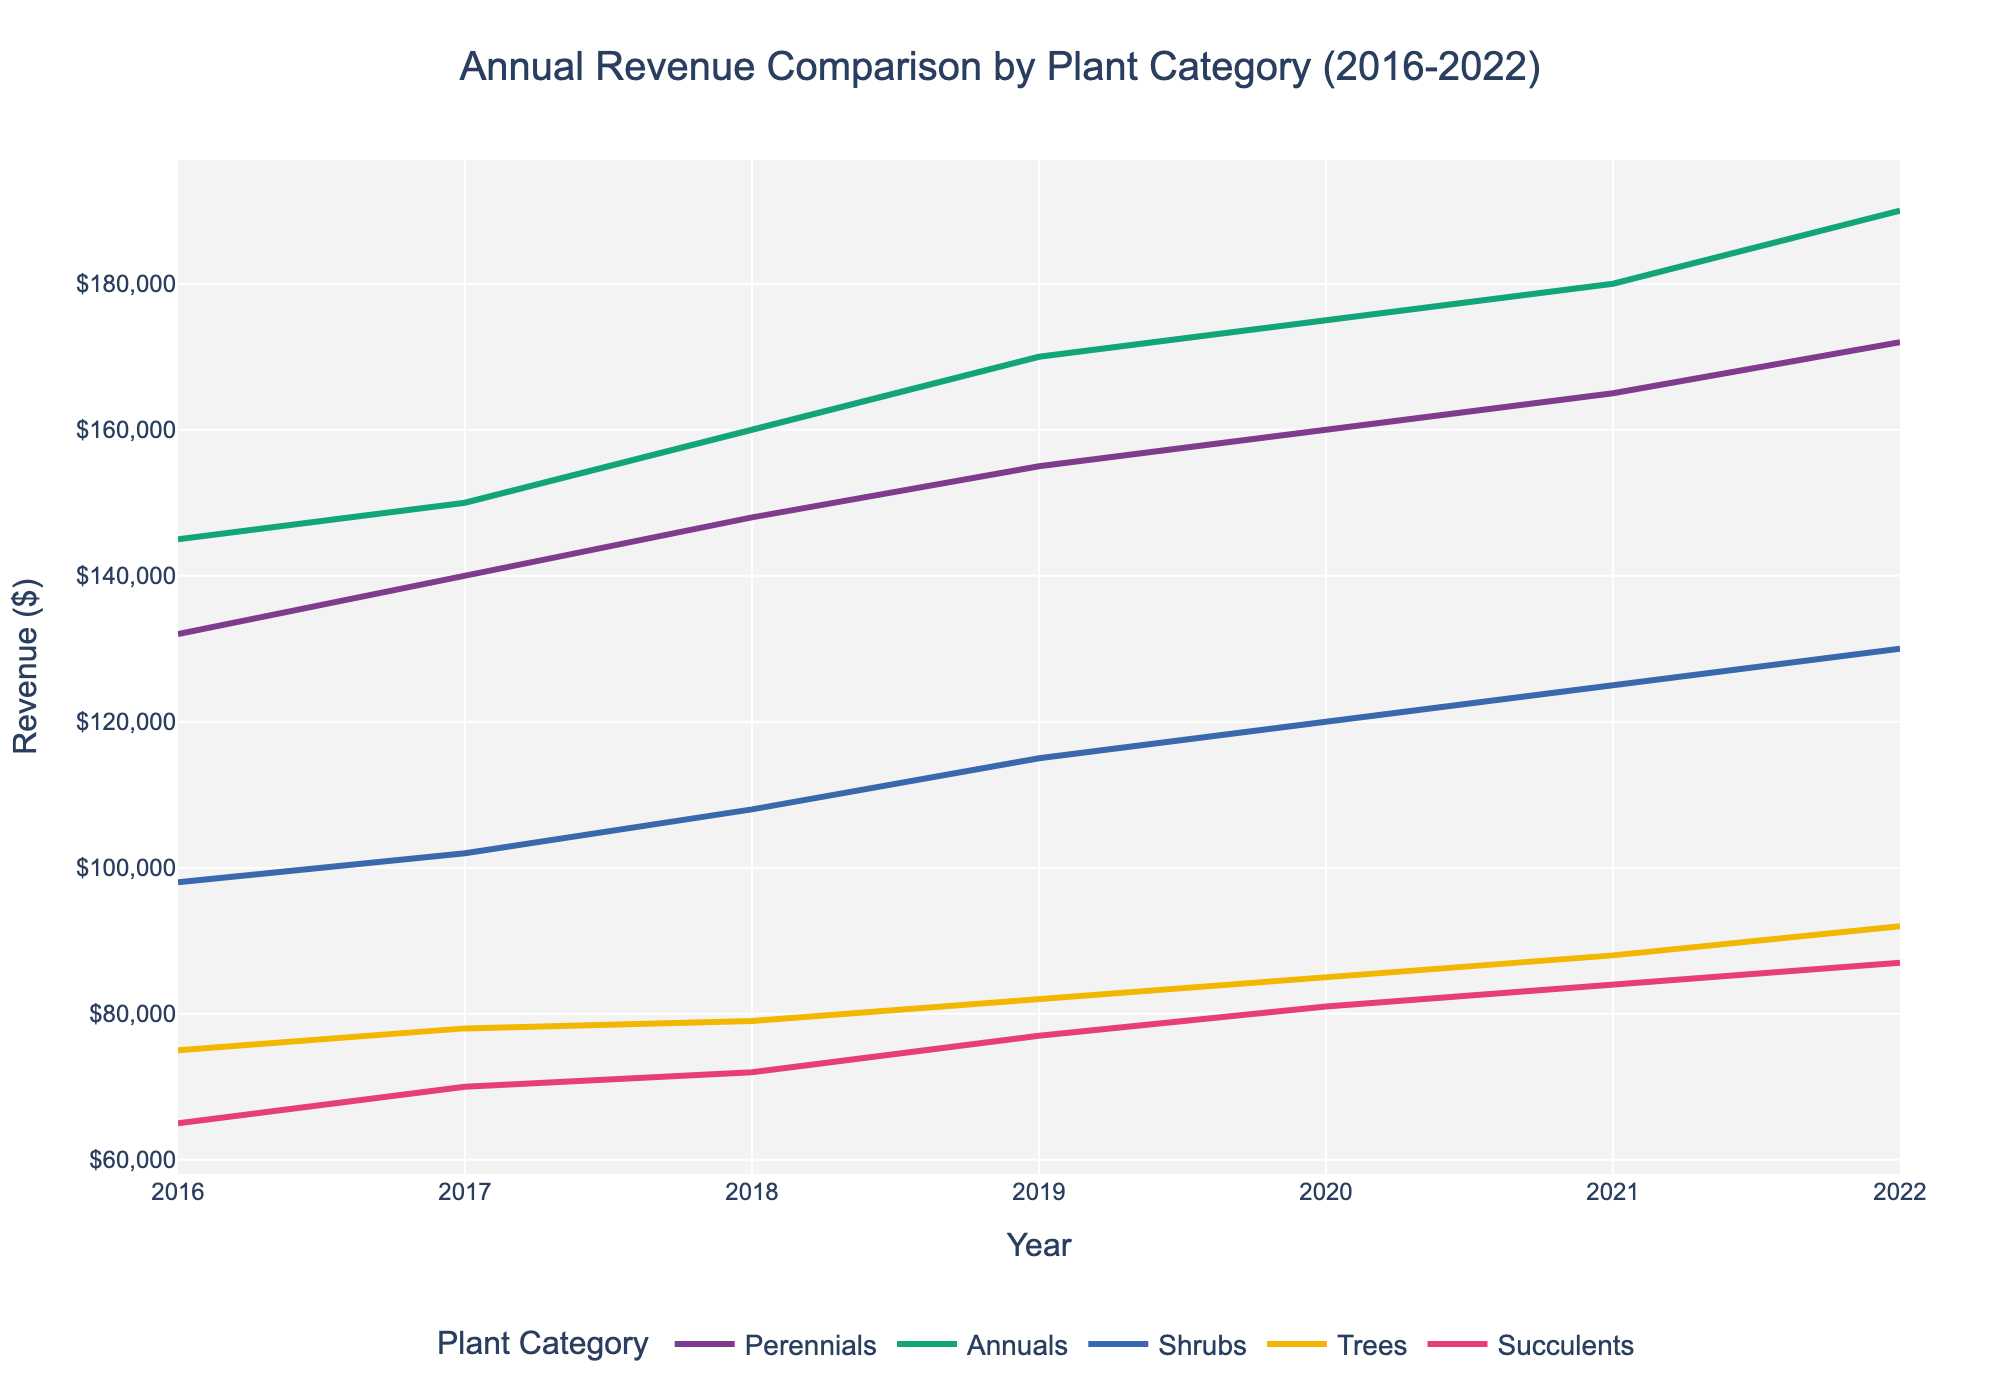Which plant category had the highest revenue in 2022? To determine the plant category with the highest revenue in 2022, look at the revenues for each category in that year. Annuals had the highest revenue of $190,000.
Answer: Annuals Which category saw the largest increase in revenue from 2016 to 2022? Calculate the revenue increase for each category between 2016 and 2022. Perennials increased from $132,000 to $172,000 (+$40,000), Annuals from $145,000 to $190,000 (+$45,000), Shrubs from $98,000 to $130,000 (+$32,000), Trees from $75,000 to $92,000 (+$17,000), and Succulents from $65,000 to $87,000 (+$22,000). Annuals had the largest increase of $45,000.
Answer: Annuals Did any category experience a revenue decrease between any two consecutive years? Compare the revenues for each category between consecutive years from 2016 to 2022. None of the categories showed a decrease in revenue between consecutive years.
Answer: No By how much did Shrubs' revenue increase from 2018 to 2022? Shrubs' revenue in 2018 was $108,000 and in 2022 it was $130,000. Subtract the revenue of 2018 from that of 2022 to find the increase: $130,000 - $108,000 = $22,000.
Answer: $22,000 Between which two consecutive years did Succulents see the highest revenue growth? Calculate the revenue growth for Succulents between consecutive years: from 2016 to 2017 ($70,000-$65,000=$5,000), 2017 to 2018 ($72,000-$70,000=$2,000), 2018 to 2019 ($77,000-$72,000=$5,000), 2019 to 2020 ($81,000-$77,000=$4,000), 2020 to 2021 ($84,000-$81,000=$3,000), and 2021 to 2022 ($87,000-$84,000=$3,000). The highest revenue growth was from 2016 to 2017 and from 2018 to 2019, each $5,000.
Answer: 2016 to 2017 and 2018 to 2019 What was the total revenue for all plant categories combined in 2020? Sum up the revenues for all categories in 2020: Perennials ($160,000), Annuals ($175,000), Shrubs ($120,000), Trees ($85,000), and Succulents ($81,000). So, the total revenue is $160,000 + $175,000 + $120,000 + $85,000 + $81,000 = $621,000.
Answer: $621,000 Which plant category had the lowest revenue in 2019? Look at the revenues for each category in 2019: Perennials ($155,000), Annuals ($170,000), Shrubs ($115,000), Trees ($82,000), and Succulents ($77,000). Succulents had the lowest revenue that year.
Answer: Succulents By what percentage did the revenue of Trees increase from 2016 to 2022? First, find the increase in revenue for Trees from 2016 to 2022: $92,000 (2022) - $75,000 (2016) = $17,000. Then, calculate the percentage increase: ($17,000 / $75,000) * 100% = 22.67%.
Answer: 22.67% 